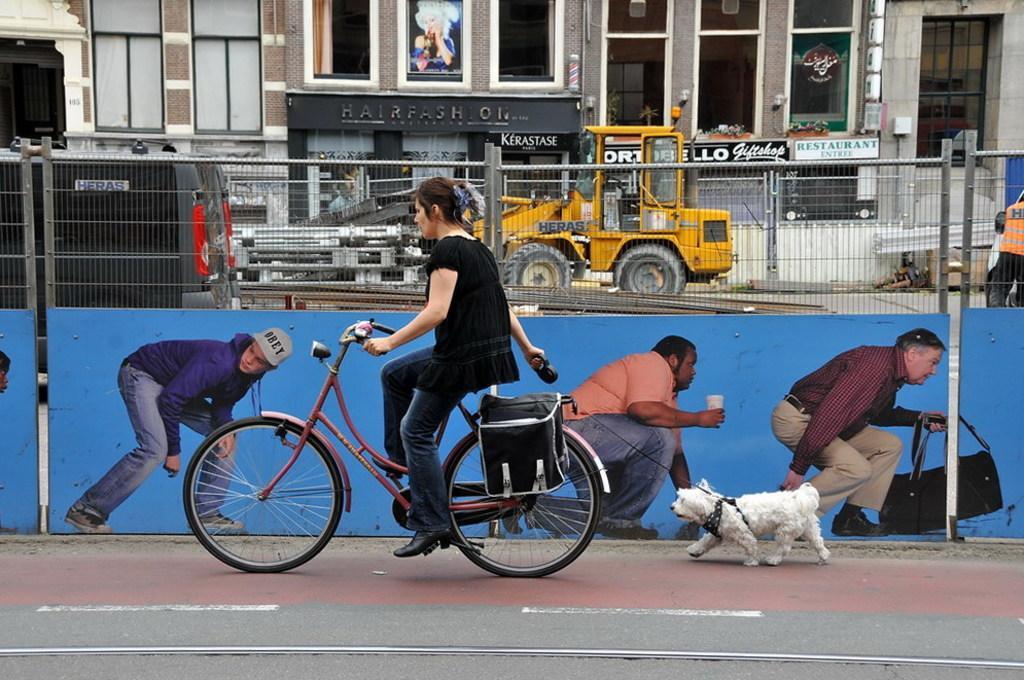Can you describe this image briefly? In the center we can see woman riding cycle and she is holding dog. And coming to background we can see the building named as "fashion" and we can see few vehicles. 